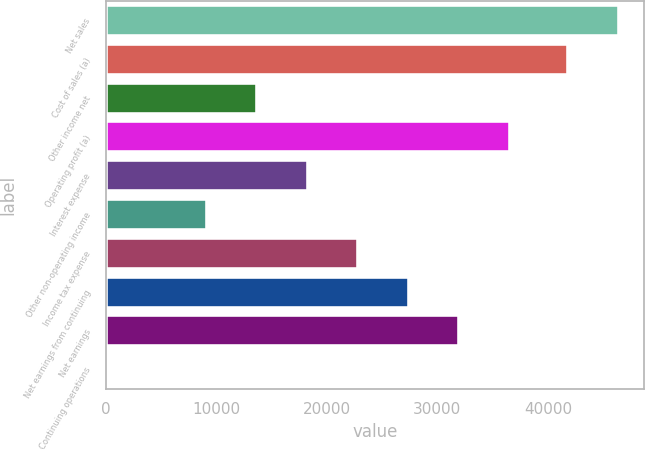Convert chart. <chart><loc_0><loc_0><loc_500><loc_500><bar_chart><fcel>Net sales<fcel>Cost of sales (a)<fcel>Other income net<fcel>Operating profit (a)<fcel>Interest expense<fcel>Other non-operating income<fcel>Income tax expense<fcel>Net earnings from continuing<fcel>Net earnings<fcel>Continuing operations<nl><fcel>46393.4<fcel>41827<fcel>13706.3<fcel>36538.2<fcel>18272.7<fcel>9139.88<fcel>22839<fcel>27405.4<fcel>31971.8<fcel>7.1<nl></chart> 